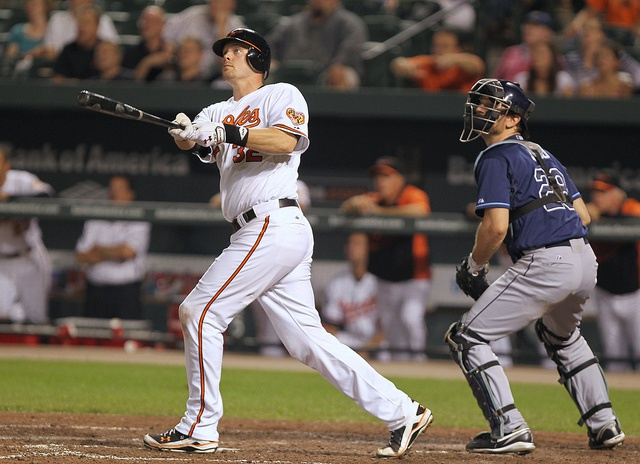Describe the objects in this image and their specific colors. I can see people in black, lavender, darkgray, and gray tones, people in black, darkgray, gray, and navy tones, people in black, gray, and maroon tones, people in black, brown, and gray tones, and people in black, gray, and darkgray tones in this image. 